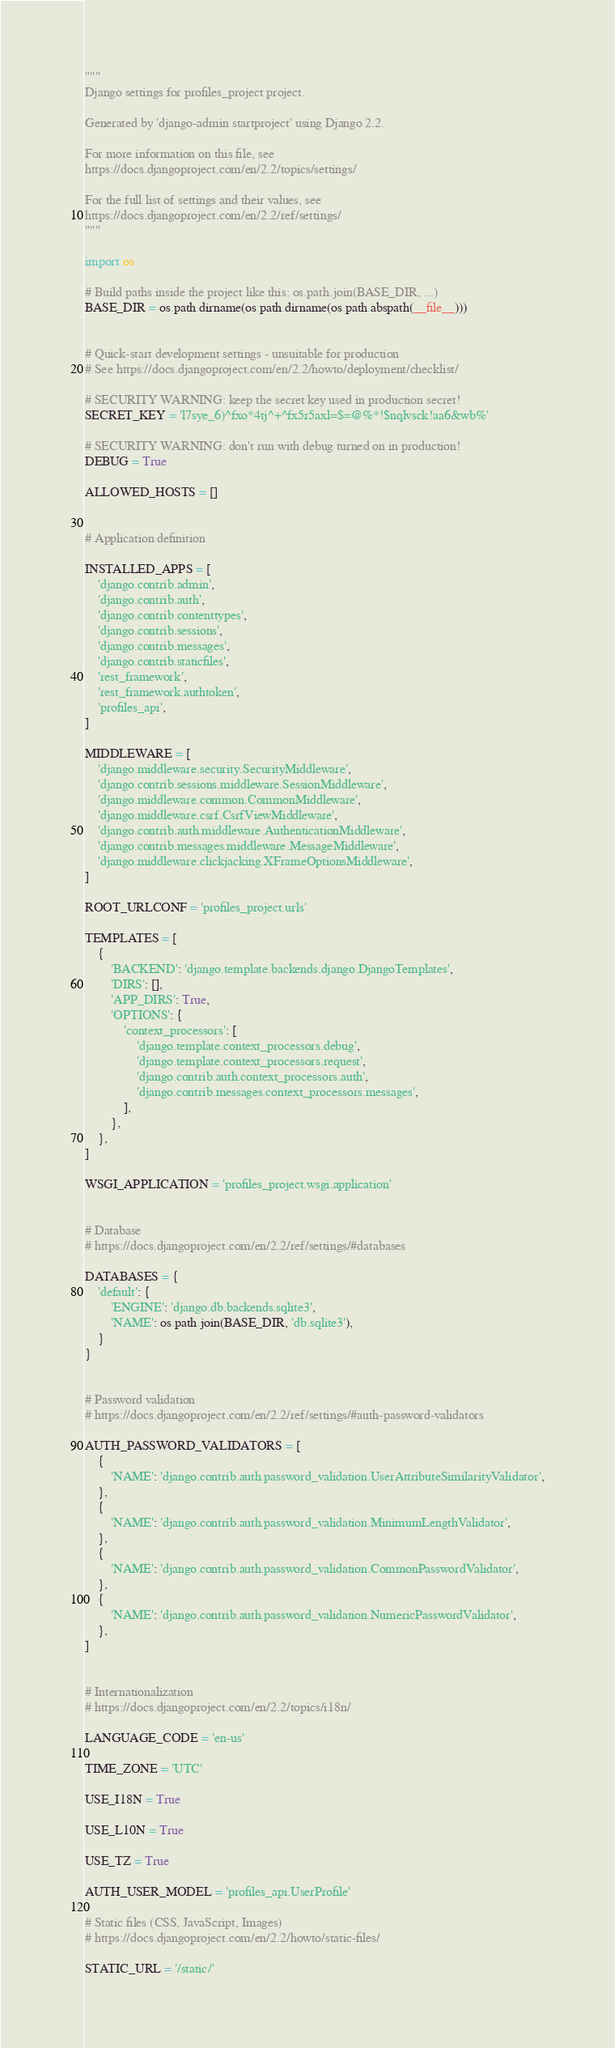<code> <loc_0><loc_0><loc_500><loc_500><_Python_>"""
Django settings for profiles_project project.

Generated by 'django-admin startproject' using Django 2.2.

For more information on this file, see
https://docs.djangoproject.com/en/2.2/topics/settings/

For the full list of settings and their values, see
https://docs.djangoproject.com/en/2.2/ref/settings/
"""

import os

# Build paths inside the project like this: os.path.join(BASE_DIR, ...)
BASE_DIR = os.path.dirname(os.path.dirname(os.path.abspath(__file__)))


# Quick-start development settings - unsuitable for production
# See https://docs.djangoproject.com/en/2.2/howto/deployment/checklist/

# SECURITY WARNING: keep the secret key used in production secret!
SECRET_KEY = 'l7sye_6)^fxo*4tj^+^fx5r5axl=$=@%*!$nqlvsck!aa6&wb%'

# SECURITY WARNING: don't run with debug turned on in production!
DEBUG = True

ALLOWED_HOSTS = []


# Application definition

INSTALLED_APPS = [
    'django.contrib.admin',
    'django.contrib.auth',
    'django.contrib.contenttypes',
    'django.contrib.sessions',
    'django.contrib.messages',
    'django.contrib.staticfiles',
    'rest_framework',
    'rest_framework.authtoken',
    'profiles_api',
]

MIDDLEWARE = [
    'django.middleware.security.SecurityMiddleware',
    'django.contrib.sessions.middleware.SessionMiddleware',
    'django.middleware.common.CommonMiddleware',
    'django.middleware.csrf.CsrfViewMiddleware',
    'django.contrib.auth.middleware.AuthenticationMiddleware',
    'django.contrib.messages.middleware.MessageMiddleware',
    'django.middleware.clickjacking.XFrameOptionsMiddleware',
]

ROOT_URLCONF = 'profiles_project.urls'

TEMPLATES = [
    {
        'BACKEND': 'django.template.backends.django.DjangoTemplates',
        'DIRS': [],
        'APP_DIRS': True,
        'OPTIONS': {
            'context_processors': [
                'django.template.context_processors.debug',
                'django.template.context_processors.request',
                'django.contrib.auth.context_processors.auth',
                'django.contrib.messages.context_processors.messages',
            ],
        },
    },
]

WSGI_APPLICATION = 'profiles_project.wsgi.application'


# Database
# https://docs.djangoproject.com/en/2.2/ref/settings/#databases

DATABASES = {
    'default': {
        'ENGINE': 'django.db.backends.sqlite3',
        'NAME': os.path.join(BASE_DIR, 'db.sqlite3'),
    }
}


# Password validation
# https://docs.djangoproject.com/en/2.2/ref/settings/#auth-password-validators

AUTH_PASSWORD_VALIDATORS = [
    {
        'NAME': 'django.contrib.auth.password_validation.UserAttributeSimilarityValidator',
    },
    {
        'NAME': 'django.contrib.auth.password_validation.MinimumLengthValidator',
    },
    {
        'NAME': 'django.contrib.auth.password_validation.CommonPasswordValidator',
    },
    {
        'NAME': 'django.contrib.auth.password_validation.NumericPasswordValidator',
    },
]


# Internationalization
# https://docs.djangoproject.com/en/2.2/topics/i18n/

LANGUAGE_CODE = 'en-us'

TIME_ZONE = 'UTC'

USE_I18N = True

USE_L10N = True

USE_TZ = True

AUTH_USER_MODEL = 'profiles_api.UserProfile'

# Static files (CSS, JavaScript, Images)
# https://docs.djangoproject.com/en/2.2/howto/static-files/

STATIC_URL = '/static/'
</code> 